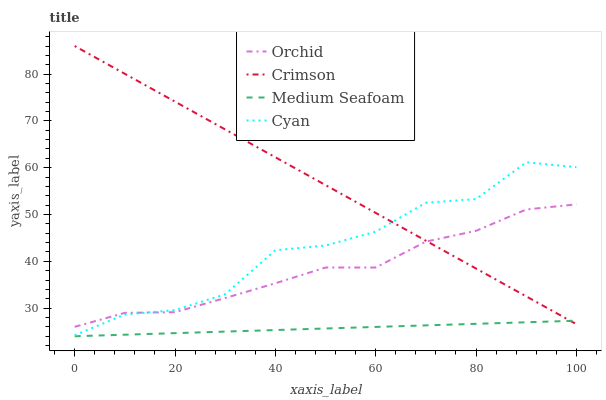Does Medium Seafoam have the minimum area under the curve?
Answer yes or no. Yes. Does Crimson have the maximum area under the curve?
Answer yes or no. Yes. Does Cyan have the minimum area under the curve?
Answer yes or no. No. Does Cyan have the maximum area under the curve?
Answer yes or no. No. Is Medium Seafoam the smoothest?
Answer yes or no. Yes. Is Cyan the roughest?
Answer yes or no. Yes. Is Cyan the smoothest?
Answer yes or no. No. Is Medium Seafoam the roughest?
Answer yes or no. No. Does Medium Seafoam have the lowest value?
Answer yes or no. Yes. Does Cyan have the lowest value?
Answer yes or no. No. Does Crimson have the highest value?
Answer yes or no. Yes. Does Cyan have the highest value?
Answer yes or no. No. Is Medium Seafoam less than Cyan?
Answer yes or no. Yes. Is Orchid greater than Medium Seafoam?
Answer yes or no. Yes. Does Orchid intersect Crimson?
Answer yes or no. Yes. Is Orchid less than Crimson?
Answer yes or no. No. Is Orchid greater than Crimson?
Answer yes or no. No. Does Medium Seafoam intersect Cyan?
Answer yes or no. No. 